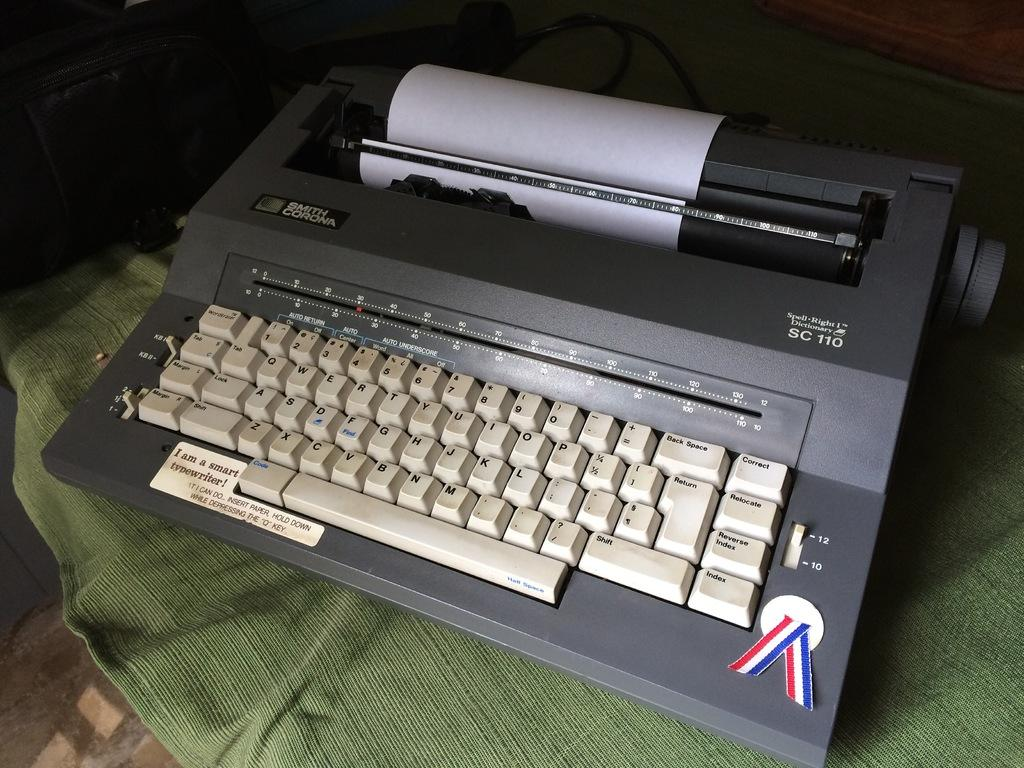<image>
Provide a brief description of the given image. The SC 110 typewriter is made by Smith Corona. 